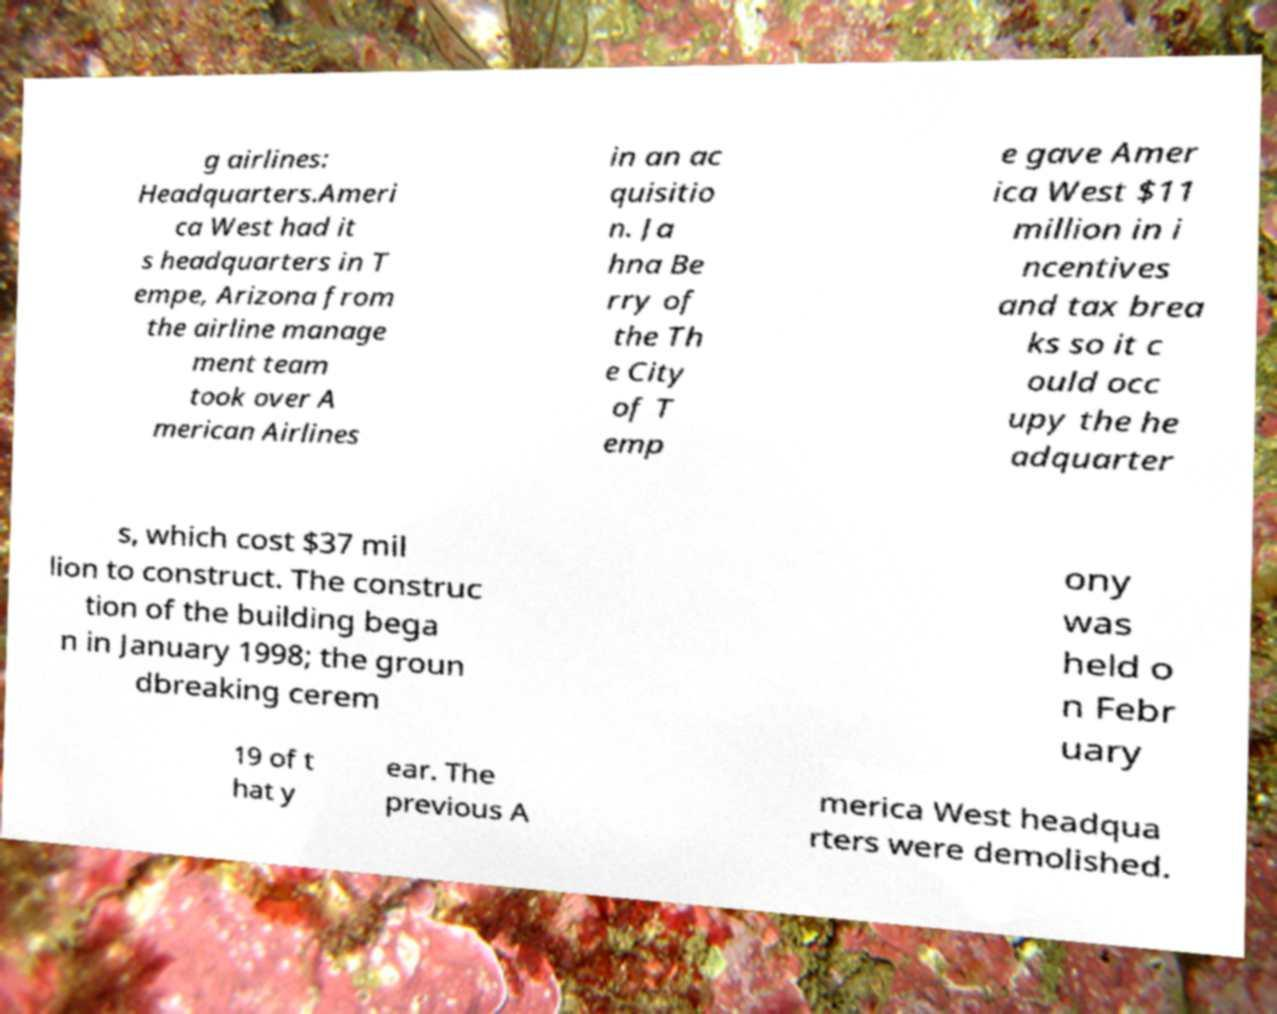Could you assist in decoding the text presented in this image and type it out clearly? g airlines: Headquarters.Ameri ca West had it s headquarters in T empe, Arizona from the airline manage ment team took over A merican Airlines in an ac quisitio n. Ja hna Be rry of the Th e City of T emp e gave Amer ica West $11 million in i ncentives and tax brea ks so it c ould occ upy the he adquarter s, which cost $37 mil lion to construct. The construc tion of the building bega n in January 1998; the groun dbreaking cerem ony was held o n Febr uary 19 of t hat y ear. The previous A merica West headqua rters were demolished. 